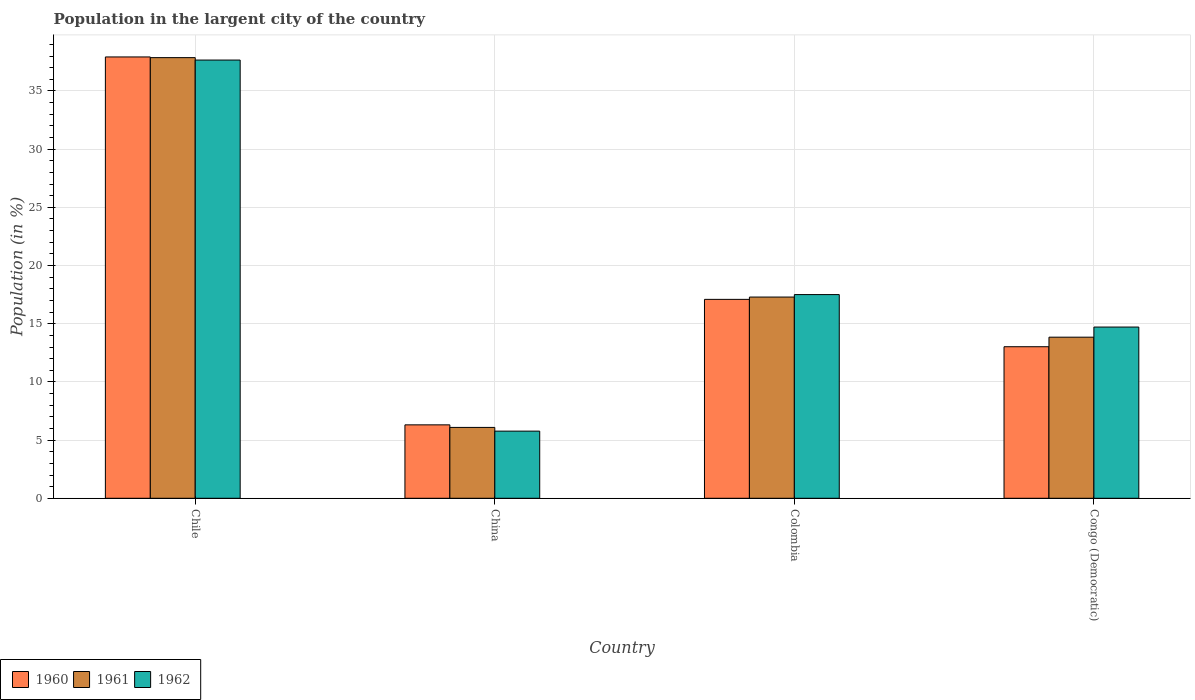Are the number of bars on each tick of the X-axis equal?
Provide a short and direct response. Yes. How many bars are there on the 1st tick from the left?
Your response must be concise. 3. What is the percentage of population in the largent city in 1960 in China?
Provide a succinct answer. 6.31. Across all countries, what is the maximum percentage of population in the largent city in 1962?
Keep it short and to the point. 37.66. Across all countries, what is the minimum percentage of population in the largent city in 1961?
Offer a very short reply. 6.09. What is the total percentage of population in the largent city in 1960 in the graph?
Give a very brief answer. 74.35. What is the difference between the percentage of population in the largent city in 1962 in China and that in Colombia?
Your answer should be compact. -11.73. What is the difference between the percentage of population in the largent city in 1960 in Colombia and the percentage of population in the largent city in 1962 in Chile?
Make the answer very short. -20.57. What is the average percentage of population in the largent city in 1960 per country?
Give a very brief answer. 18.59. What is the difference between the percentage of population in the largent city of/in 1962 and percentage of population in the largent city of/in 1960 in Chile?
Offer a terse response. -0.27. What is the ratio of the percentage of population in the largent city in 1960 in China to that in Congo (Democratic)?
Your response must be concise. 0.48. Is the percentage of population in the largent city in 1961 in Colombia less than that in Congo (Democratic)?
Your response must be concise. No. What is the difference between the highest and the second highest percentage of population in the largent city in 1960?
Provide a succinct answer. 4.07. What is the difference between the highest and the lowest percentage of population in the largent city in 1960?
Keep it short and to the point. 31.62. In how many countries, is the percentage of population in the largent city in 1961 greater than the average percentage of population in the largent city in 1961 taken over all countries?
Your response must be concise. 1. Is the sum of the percentage of population in the largent city in 1960 in Chile and China greater than the maximum percentage of population in the largent city in 1961 across all countries?
Provide a succinct answer. Yes. What does the 2nd bar from the left in China represents?
Provide a succinct answer. 1961. Are all the bars in the graph horizontal?
Your response must be concise. No. What is the difference between two consecutive major ticks on the Y-axis?
Your response must be concise. 5. Are the values on the major ticks of Y-axis written in scientific E-notation?
Make the answer very short. No. How many legend labels are there?
Offer a very short reply. 3. How are the legend labels stacked?
Your response must be concise. Horizontal. What is the title of the graph?
Your answer should be very brief. Population in the largent city of the country. Does "1964" appear as one of the legend labels in the graph?
Offer a terse response. No. What is the label or title of the X-axis?
Your answer should be compact. Country. What is the label or title of the Y-axis?
Keep it short and to the point. Population (in %). What is the Population (in %) in 1960 in Chile?
Your answer should be very brief. 37.93. What is the Population (in %) of 1961 in Chile?
Make the answer very short. 37.87. What is the Population (in %) in 1962 in Chile?
Provide a short and direct response. 37.66. What is the Population (in %) of 1960 in China?
Your answer should be very brief. 6.31. What is the Population (in %) of 1961 in China?
Your answer should be very brief. 6.09. What is the Population (in %) in 1962 in China?
Your answer should be compact. 5.77. What is the Population (in %) in 1960 in Colombia?
Your answer should be very brief. 17.09. What is the Population (in %) of 1961 in Colombia?
Your answer should be compact. 17.29. What is the Population (in %) in 1962 in Colombia?
Provide a short and direct response. 17.5. What is the Population (in %) of 1960 in Congo (Democratic)?
Your answer should be compact. 13.02. What is the Population (in %) in 1961 in Congo (Democratic)?
Make the answer very short. 13.84. What is the Population (in %) of 1962 in Congo (Democratic)?
Give a very brief answer. 14.71. Across all countries, what is the maximum Population (in %) of 1960?
Offer a very short reply. 37.93. Across all countries, what is the maximum Population (in %) in 1961?
Keep it short and to the point. 37.87. Across all countries, what is the maximum Population (in %) of 1962?
Provide a short and direct response. 37.66. Across all countries, what is the minimum Population (in %) in 1960?
Your response must be concise. 6.31. Across all countries, what is the minimum Population (in %) in 1961?
Offer a terse response. 6.09. Across all countries, what is the minimum Population (in %) in 1962?
Ensure brevity in your answer.  5.77. What is the total Population (in %) of 1960 in the graph?
Your response must be concise. 74.35. What is the total Population (in %) of 1961 in the graph?
Make the answer very short. 75.09. What is the total Population (in %) in 1962 in the graph?
Ensure brevity in your answer.  75.65. What is the difference between the Population (in %) in 1960 in Chile and that in China?
Keep it short and to the point. 31.62. What is the difference between the Population (in %) in 1961 in Chile and that in China?
Your answer should be very brief. 31.78. What is the difference between the Population (in %) of 1962 in Chile and that in China?
Your answer should be compact. 31.89. What is the difference between the Population (in %) of 1960 in Chile and that in Colombia?
Offer a terse response. 20.83. What is the difference between the Population (in %) of 1961 in Chile and that in Colombia?
Ensure brevity in your answer.  20.57. What is the difference between the Population (in %) in 1962 in Chile and that in Colombia?
Offer a very short reply. 20.16. What is the difference between the Population (in %) of 1960 in Chile and that in Congo (Democratic)?
Your answer should be very brief. 24.9. What is the difference between the Population (in %) in 1961 in Chile and that in Congo (Democratic)?
Give a very brief answer. 24.02. What is the difference between the Population (in %) in 1962 in Chile and that in Congo (Democratic)?
Provide a short and direct response. 22.95. What is the difference between the Population (in %) of 1960 in China and that in Colombia?
Give a very brief answer. -10.78. What is the difference between the Population (in %) in 1961 in China and that in Colombia?
Your answer should be compact. -11.2. What is the difference between the Population (in %) in 1962 in China and that in Colombia?
Provide a succinct answer. -11.73. What is the difference between the Population (in %) of 1960 in China and that in Congo (Democratic)?
Your answer should be very brief. -6.71. What is the difference between the Population (in %) in 1961 in China and that in Congo (Democratic)?
Your answer should be very brief. -7.75. What is the difference between the Population (in %) of 1962 in China and that in Congo (Democratic)?
Give a very brief answer. -8.94. What is the difference between the Population (in %) in 1960 in Colombia and that in Congo (Democratic)?
Ensure brevity in your answer.  4.07. What is the difference between the Population (in %) of 1961 in Colombia and that in Congo (Democratic)?
Give a very brief answer. 3.45. What is the difference between the Population (in %) of 1962 in Colombia and that in Congo (Democratic)?
Offer a very short reply. 2.79. What is the difference between the Population (in %) of 1960 in Chile and the Population (in %) of 1961 in China?
Make the answer very short. 31.84. What is the difference between the Population (in %) of 1960 in Chile and the Population (in %) of 1962 in China?
Your response must be concise. 32.16. What is the difference between the Population (in %) of 1961 in Chile and the Population (in %) of 1962 in China?
Offer a very short reply. 32.1. What is the difference between the Population (in %) in 1960 in Chile and the Population (in %) in 1961 in Colombia?
Your answer should be compact. 20.63. What is the difference between the Population (in %) in 1960 in Chile and the Population (in %) in 1962 in Colombia?
Make the answer very short. 20.42. What is the difference between the Population (in %) in 1961 in Chile and the Population (in %) in 1962 in Colombia?
Your response must be concise. 20.36. What is the difference between the Population (in %) in 1960 in Chile and the Population (in %) in 1961 in Congo (Democratic)?
Make the answer very short. 24.08. What is the difference between the Population (in %) of 1960 in Chile and the Population (in %) of 1962 in Congo (Democratic)?
Make the answer very short. 23.21. What is the difference between the Population (in %) in 1961 in Chile and the Population (in %) in 1962 in Congo (Democratic)?
Your answer should be compact. 23.15. What is the difference between the Population (in %) of 1960 in China and the Population (in %) of 1961 in Colombia?
Offer a very short reply. -10.98. What is the difference between the Population (in %) in 1960 in China and the Population (in %) in 1962 in Colombia?
Your response must be concise. -11.19. What is the difference between the Population (in %) of 1961 in China and the Population (in %) of 1962 in Colombia?
Provide a succinct answer. -11.41. What is the difference between the Population (in %) of 1960 in China and the Population (in %) of 1961 in Congo (Democratic)?
Ensure brevity in your answer.  -7.53. What is the difference between the Population (in %) in 1960 in China and the Population (in %) in 1962 in Congo (Democratic)?
Offer a terse response. -8.4. What is the difference between the Population (in %) of 1961 in China and the Population (in %) of 1962 in Congo (Democratic)?
Offer a terse response. -8.62. What is the difference between the Population (in %) of 1960 in Colombia and the Population (in %) of 1961 in Congo (Democratic)?
Offer a very short reply. 3.25. What is the difference between the Population (in %) of 1960 in Colombia and the Population (in %) of 1962 in Congo (Democratic)?
Your answer should be very brief. 2.38. What is the difference between the Population (in %) of 1961 in Colombia and the Population (in %) of 1962 in Congo (Democratic)?
Make the answer very short. 2.58. What is the average Population (in %) in 1960 per country?
Your response must be concise. 18.59. What is the average Population (in %) of 1961 per country?
Provide a succinct answer. 18.77. What is the average Population (in %) in 1962 per country?
Provide a short and direct response. 18.91. What is the difference between the Population (in %) of 1960 and Population (in %) of 1962 in Chile?
Your response must be concise. 0.27. What is the difference between the Population (in %) in 1961 and Population (in %) in 1962 in Chile?
Your answer should be very brief. 0.21. What is the difference between the Population (in %) of 1960 and Population (in %) of 1961 in China?
Make the answer very short. 0.22. What is the difference between the Population (in %) in 1960 and Population (in %) in 1962 in China?
Your answer should be compact. 0.54. What is the difference between the Population (in %) in 1961 and Population (in %) in 1962 in China?
Your answer should be very brief. 0.32. What is the difference between the Population (in %) in 1960 and Population (in %) in 1961 in Colombia?
Your response must be concise. -0.2. What is the difference between the Population (in %) in 1960 and Population (in %) in 1962 in Colombia?
Your response must be concise. -0.41. What is the difference between the Population (in %) of 1961 and Population (in %) of 1962 in Colombia?
Provide a succinct answer. -0.21. What is the difference between the Population (in %) in 1960 and Population (in %) in 1961 in Congo (Democratic)?
Offer a terse response. -0.82. What is the difference between the Population (in %) of 1960 and Population (in %) of 1962 in Congo (Democratic)?
Make the answer very short. -1.69. What is the difference between the Population (in %) in 1961 and Population (in %) in 1962 in Congo (Democratic)?
Make the answer very short. -0.87. What is the ratio of the Population (in %) in 1960 in Chile to that in China?
Give a very brief answer. 6.01. What is the ratio of the Population (in %) in 1961 in Chile to that in China?
Provide a short and direct response. 6.22. What is the ratio of the Population (in %) of 1962 in Chile to that in China?
Provide a succinct answer. 6.53. What is the ratio of the Population (in %) of 1960 in Chile to that in Colombia?
Give a very brief answer. 2.22. What is the ratio of the Population (in %) of 1961 in Chile to that in Colombia?
Your response must be concise. 2.19. What is the ratio of the Population (in %) in 1962 in Chile to that in Colombia?
Make the answer very short. 2.15. What is the ratio of the Population (in %) of 1960 in Chile to that in Congo (Democratic)?
Offer a terse response. 2.91. What is the ratio of the Population (in %) of 1961 in Chile to that in Congo (Democratic)?
Ensure brevity in your answer.  2.74. What is the ratio of the Population (in %) in 1962 in Chile to that in Congo (Democratic)?
Your answer should be compact. 2.56. What is the ratio of the Population (in %) in 1960 in China to that in Colombia?
Provide a short and direct response. 0.37. What is the ratio of the Population (in %) of 1961 in China to that in Colombia?
Your answer should be very brief. 0.35. What is the ratio of the Population (in %) in 1962 in China to that in Colombia?
Provide a short and direct response. 0.33. What is the ratio of the Population (in %) of 1960 in China to that in Congo (Democratic)?
Provide a succinct answer. 0.48. What is the ratio of the Population (in %) in 1961 in China to that in Congo (Democratic)?
Offer a very short reply. 0.44. What is the ratio of the Population (in %) in 1962 in China to that in Congo (Democratic)?
Your answer should be very brief. 0.39. What is the ratio of the Population (in %) of 1960 in Colombia to that in Congo (Democratic)?
Offer a very short reply. 1.31. What is the ratio of the Population (in %) in 1961 in Colombia to that in Congo (Democratic)?
Offer a terse response. 1.25. What is the ratio of the Population (in %) of 1962 in Colombia to that in Congo (Democratic)?
Make the answer very short. 1.19. What is the difference between the highest and the second highest Population (in %) of 1960?
Keep it short and to the point. 20.83. What is the difference between the highest and the second highest Population (in %) of 1961?
Your answer should be very brief. 20.57. What is the difference between the highest and the second highest Population (in %) in 1962?
Ensure brevity in your answer.  20.16. What is the difference between the highest and the lowest Population (in %) of 1960?
Offer a very short reply. 31.62. What is the difference between the highest and the lowest Population (in %) in 1961?
Give a very brief answer. 31.78. What is the difference between the highest and the lowest Population (in %) in 1962?
Ensure brevity in your answer.  31.89. 